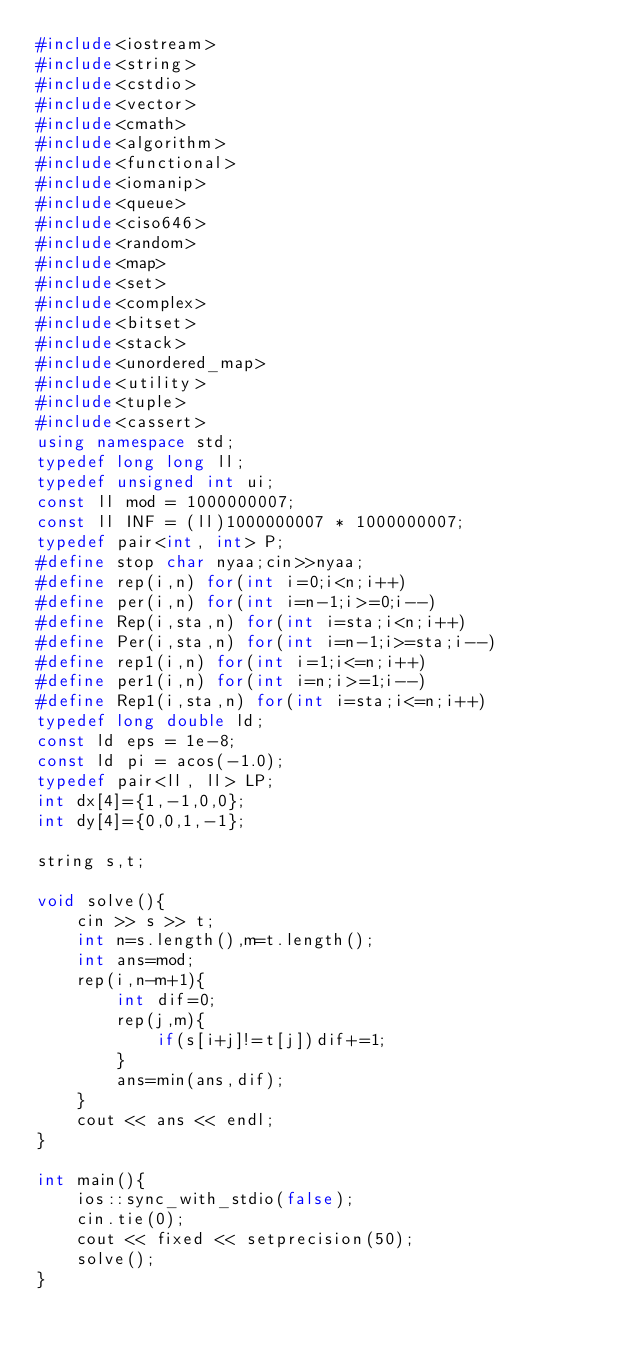<code> <loc_0><loc_0><loc_500><loc_500><_C++_>#include<iostream>
#include<string>
#include<cstdio>
#include<vector>
#include<cmath>
#include<algorithm>
#include<functional>
#include<iomanip>
#include<queue>
#include<ciso646>
#include<random>
#include<map>
#include<set>
#include<complex>
#include<bitset>
#include<stack>
#include<unordered_map>
#include<utility>
#include<tuple>
#include<cassert>
using namespace std;
typedef long long ll;
typedef unsigned int ui;
const ll mod = 1000000007;
const ll INF = (ll)1000000007 * 1000000007;
typedef pair<int, int> P;
#define stop char nyaa;cin>>nyaa;
#define rep(i,n) for(int i=0;i<n;i++)
#define per(i,n) for(int i=n-1;i>=0;i--)
#define Rep(i,sta,n) for(int i=sta;i<n;i++)
#define Per(i,sta,n) for(int i=n-1;i>=sta;i--)
#define rep1(i,n) for(int i=1;i<=n;i++)
#define per1(i,n) for(int i=n;i>=1;i--)
#define Rep1(i,sta,n) for(int i=sta;i<=n;i++)
typedef long double ld;
const ld eps = 1e-8;
const ld pi = acos(-1.0);
typedef pair<ll, ll> LP;
int dx[4]={1,-1,0,0};
int dy[4]={0,0,1,-1};

string s,t;

void solve(){
    cin >> s >> t;
    int n=s.length(),m=t.length();
    int ans=mod;
    rep(i,n-m+1){
        int dif=0;
        rep(j,m){
            if(s[i+j]!=t[j])dif+=1;
        }
        ans=min(ans,dif);
    }
    cout << ans << endl;
}

int main(){
    ios::sync_with_stdio(false);
    cin.tie(0);
    cout << fixed << setprecision(50);
    solve();
}</code> 